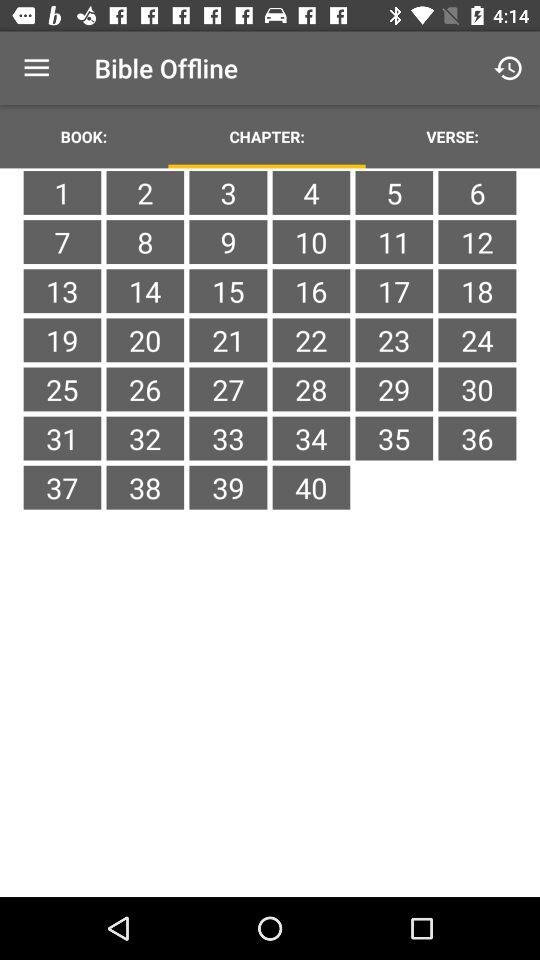Which option of the "Bible Offline" are we now on? You are now on the "CHAPTER:" option. 